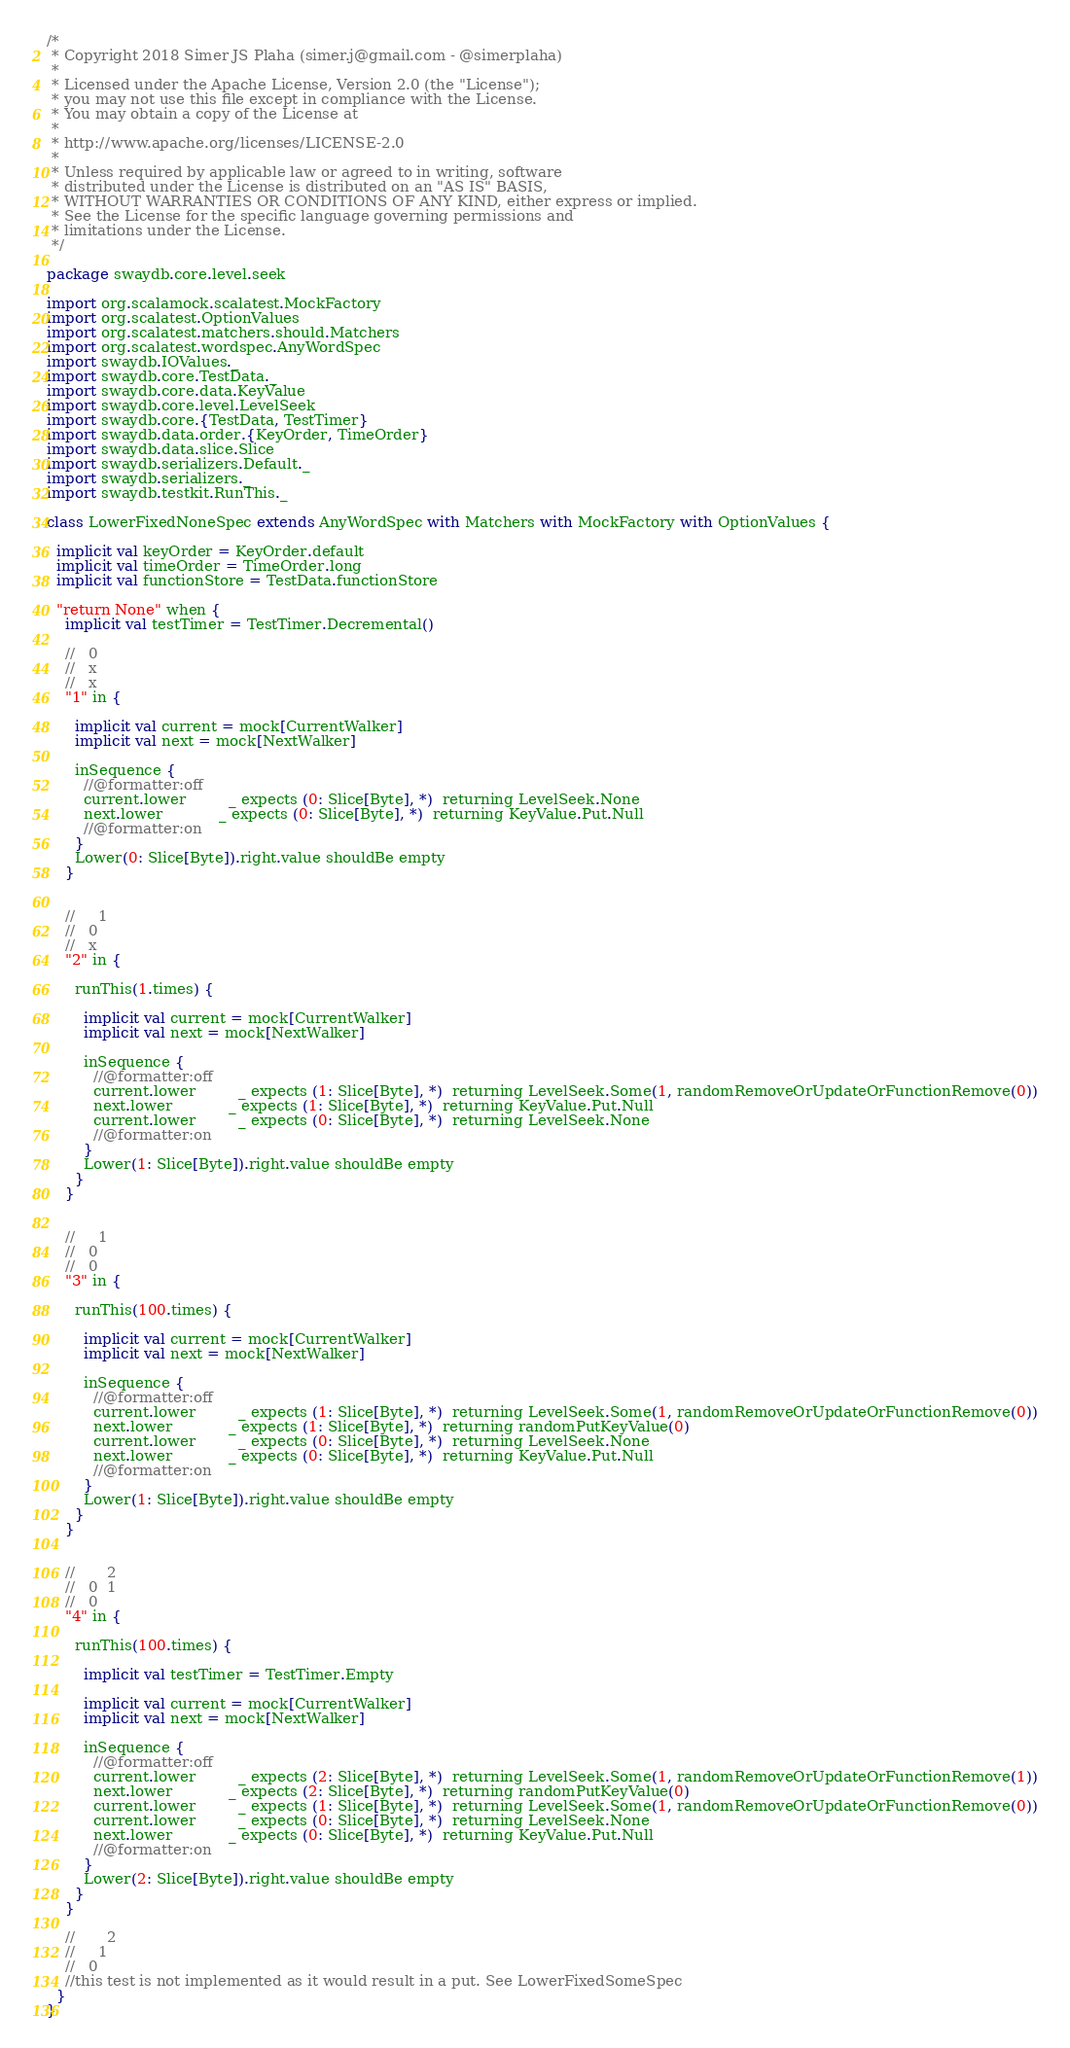<code> <loc_0><loc_0><loc_500><loc_500><_Scala_>/*
 * Copyright 2018 Simer JS Plaha (simer.j@gmail.com - @simerplaha)
 *
 * Licensed under the Apache License, Version 2.0 (the "License");
 * you may not use this file except in compliance with the License.
 * You may obtain a copy of the License at
 *
 * http://www.apache.org/licenses/LICENSE-2.0
 *
 * Unless required by applicable law or agreed to in writing, software
 * distributed under the License is distributed on an "AS IS" BASIS,
 * WITHOUT WARRANTIES OR CONDITIONS OF ANY KIND, either express or implied.
 * See the License for the specific language governing permissions and
 * limitations under the License.
 */

package swaydb.core.level.seek

import org.scalamock.scalatest.MockFactory
import org.scalatest.OptionValues
import org.scalatest.matchers.should.Matchers
import org.scalatest.wordspec.AnyWordSpec
import swaydb.IOValues._
import swaydb.core.TestData._
import swaydb.core.data.KeyValue
import swaydb.core.level.LevelSeek
import swaydb.core.{TestData, TestTimer}
import swaydb.data.order.{KeyOrder, TimeOrder}
import swaydb.data.slice.Slice
import swaydb.serializers.Default._
import swaydb.serializers._
import swaydb.testkit.RunThis._

class LowerFixedNoneSpec extends AnyWordSpec with Matchers with MockFactory with OptionValues {

  implicit val keyOrder = KeyOrder.default
  implicit val timeOrder = TimeOrder.long
  implicit val functionStore = TestData.functionStore

  "return None" when {
    implicit val testTimer = TestTimer.Decremental()

    //   0
    //   x
    //   x
    "1" in {

      implicit val current = mock[CurrentWalker]
      implicit val next = mock[NextWalker]

      inSequence {
        //@formatter:off
        current.lower         _ expects (0: Slice[Byte], *)  returning LevelSeek.None
        next.lower            _ expects (0: Slice[Byte], *)  returning KeyValue.Put.Null
        //@formatter:on
      }
      Lower(0: Slice[Byte]).right.value shouldBe empty
    }


    //     1
    //   0
    //   x
    "2" in {

      runThis(1.times) {

        implicit val current = mock[CurrentWalker]
        implicit val next = mock[NextWalker]

        inSequence {
          //@formatter:off
          current.lower         _ expects (1: Slice[Byte], *)  returning LevelSeek.Some(1, randomRemoveOrUpdateOrFunctionRemove(0))
          next.lower            _ expects (1: Slice[Byte], *)  returning KeyValue.Put.Null
          current.lower         _ expects (0: Slice[Byte], *)  returning LevelSeek.None
          //@formatter:on
        }
        Lower(1: Slice[Byte]).right.value shouldBe empty
      }
    }


    //     1
    //   0
    //   0
    "3" in {

      runThis(100.times) {

        implicit val current = mock[CurrentWalker]
        implicit val next = mock[NextWalker]

        inSequence {
          //@formatter:off
          current.lower         _ expects (1: Slice[Byte], *)  returning LevelSeek.Some(1, randomRemoveOrUpdateOrFunctionRemove(0))
          next.lower            _ expects (1: Slice[Byte], *)  returning randomPutKeyValue(0)
          current.lower         _ expects (0: Slice[Byte], *)  returning LevelSeek.None
          next.lower            _ expects (0: Slice[Byte], *)  returning KeyValue.Put.Null
          //@formatter:on
        }
        Lower(1: Slice[Byte]).right.value shouldBe empty
      }
    }


    //       2
    //   0  1
    //   0
    "4" in {

      runThis(100.times) {

        implicit val testTimer = TestTimer.Empty

        implicit val current = mock[CurrentWalker]
        implicit val next = mock[NextWalker]

        inSequence {
          //@formatter:off
          current.lower         _ expects (2: Slice[Byte], *)  returning LevelSeek.Some(1, randomRemoveOrUpdateOrFunctionRemove(1))
          next.lower            _ expects (2: Slice[Byte], *)  returning randomPutKeyValue(0)
          current.lower         _ expects (1: Slice[Byte], *)  returning LevelSeek.Some(1, randomRemoveOrUpdateOrFunctionRemove(0))
          current.lower         _ expects (0: Slice[Byte], *)  returning LevelSeek.None
          next.lower            _ expects (0: Slice[Byte], *)  returning KeyValue.Put.Null
          //@formatter:on
        }
        Lower(2: Slice[Byte]).right.value shouldBe empty
      }
    }

    //       2
    //     1
    //   0
    //this test is not implemented as it would result in a put. See LowerFixedSomeSpec
  }
}
</code> 